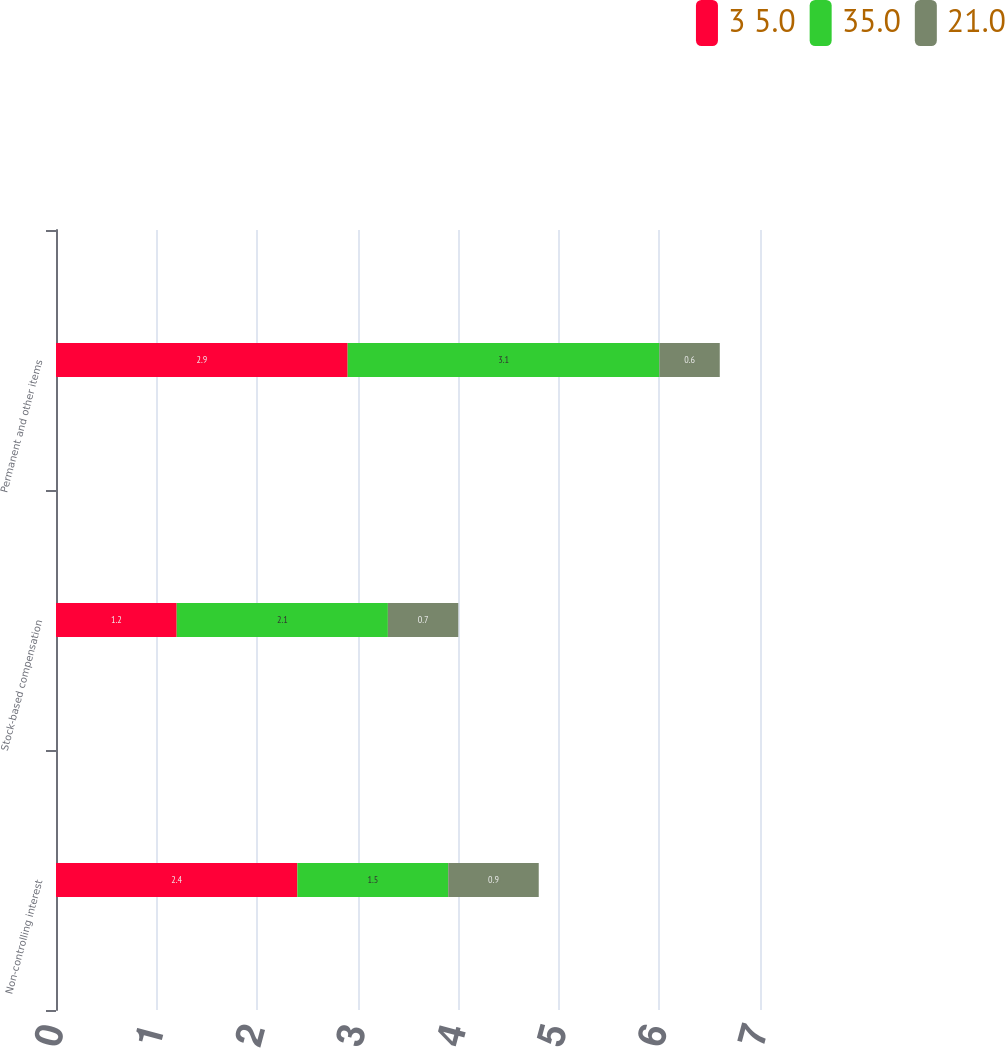Convert chart to OTSL. <chart><loc_0><loc_0><loc_500><loc_500><stacked_bar_chart><ecel><fcel>Non-controlling interest<fcel>Stock-based compensation<fcel>Permanent and other items<nl><fcel>3 5.0<fcel>2.4<fcel>1.2<fcel>2.9<nl><fcel>35.0<fcel>1.5<fcel>2.1<fcel>3.1<nl><fcel>21.0<fcel>0.9<fcel>0.7<fcel>0.6<nl></chart> 